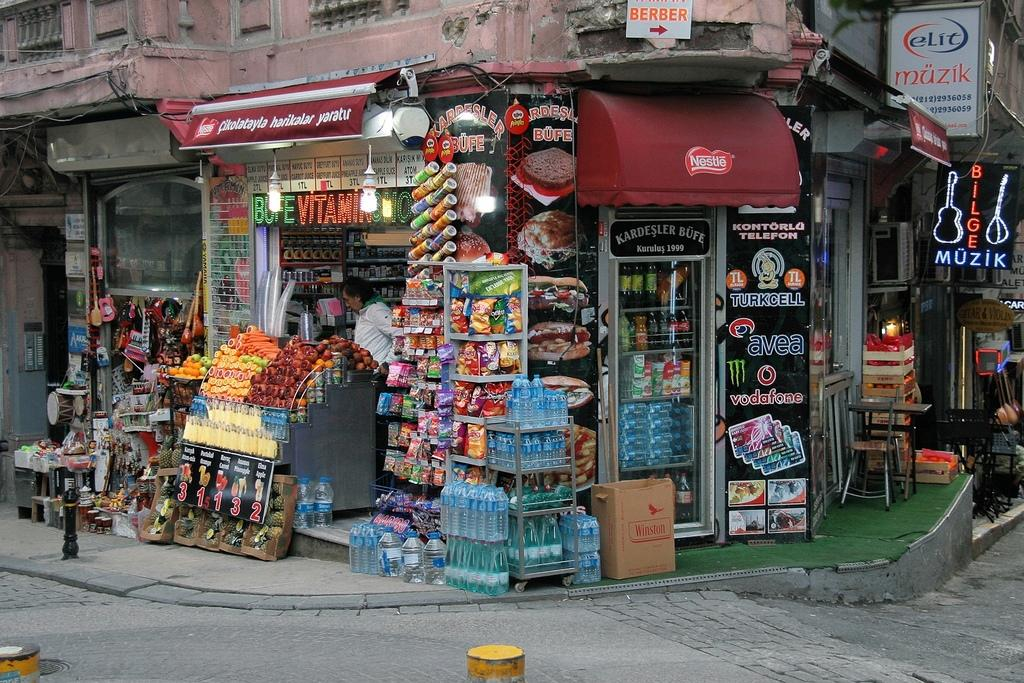<image>
Summarize the visual content of the image. A corner shop with a sign above it that lets people know the Berber is to the right. 